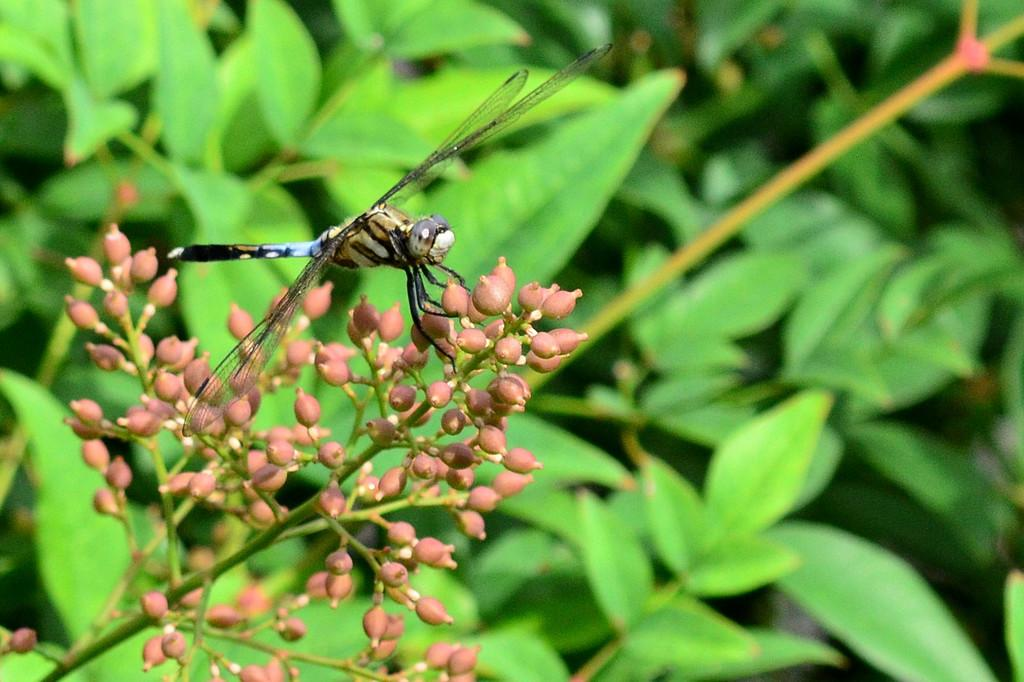What insect is present in the image? There is a dragonfly in the image. What is the dragonfly resting on? The dragonfly is on flower buds. What color are the flower buds? The flower buds are pink in color. What can be seen in the background of the image? There are plants in the background of the image. What color are the plants? The plants are green in color. What type of noise can be heard coming from the dragonfly in the image? Dragonflies do not make noise, so there is no noise coming from the dragonfly in the image. 